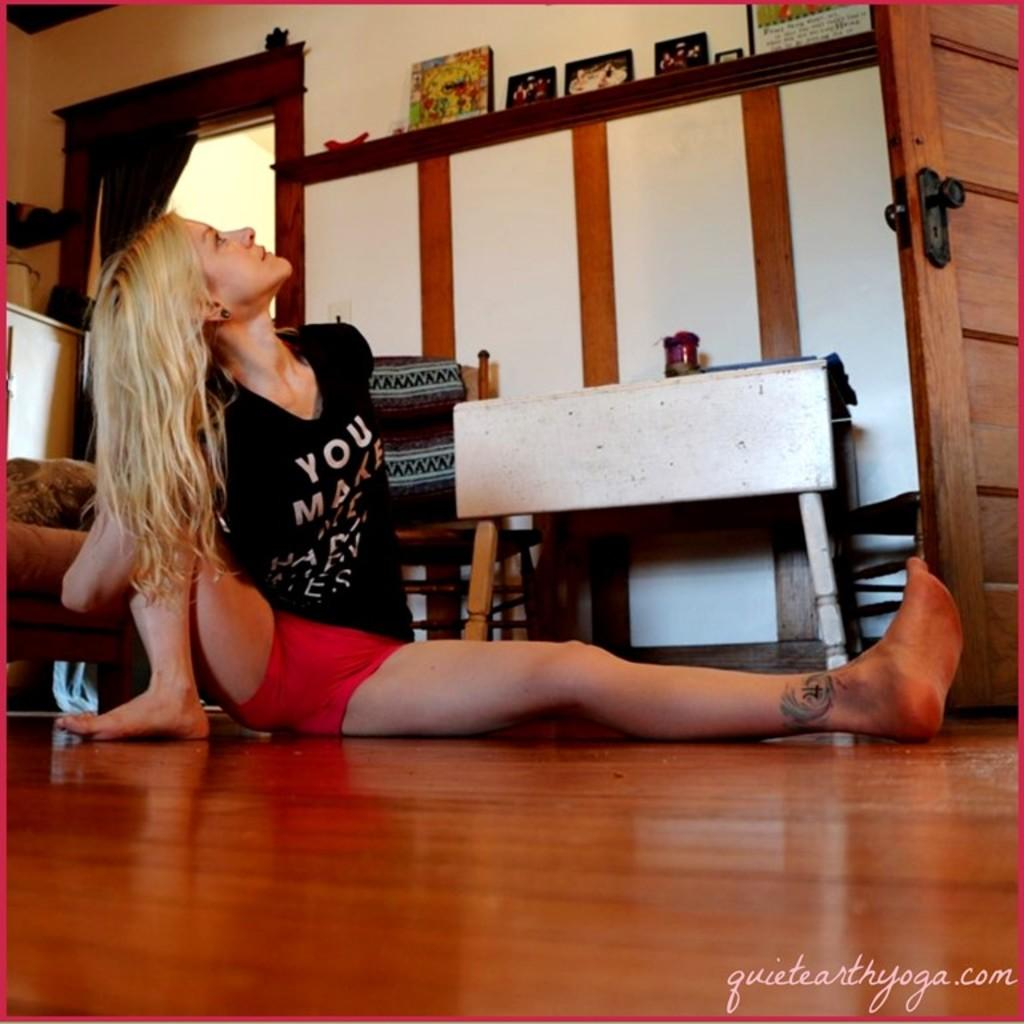What is the woman in the image doing? The woman is sitting on the floor. What is the woman wearing in the image? The woman is wearing a black t-shirt. What can be seen in the background of the image? There is a wall in the background of the image, and there are photo frames on a desk. What color is the crayon the woman is using to draw in the image? There is no crayon or drawing activity present in the image. 